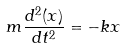Convert formula to latex. <formula><loc_0><loc_0><loc_500><loc_500>m \frac { d ^ { 2 } ( x ) } { d t ^ { 2 } } = - k x</formula> 